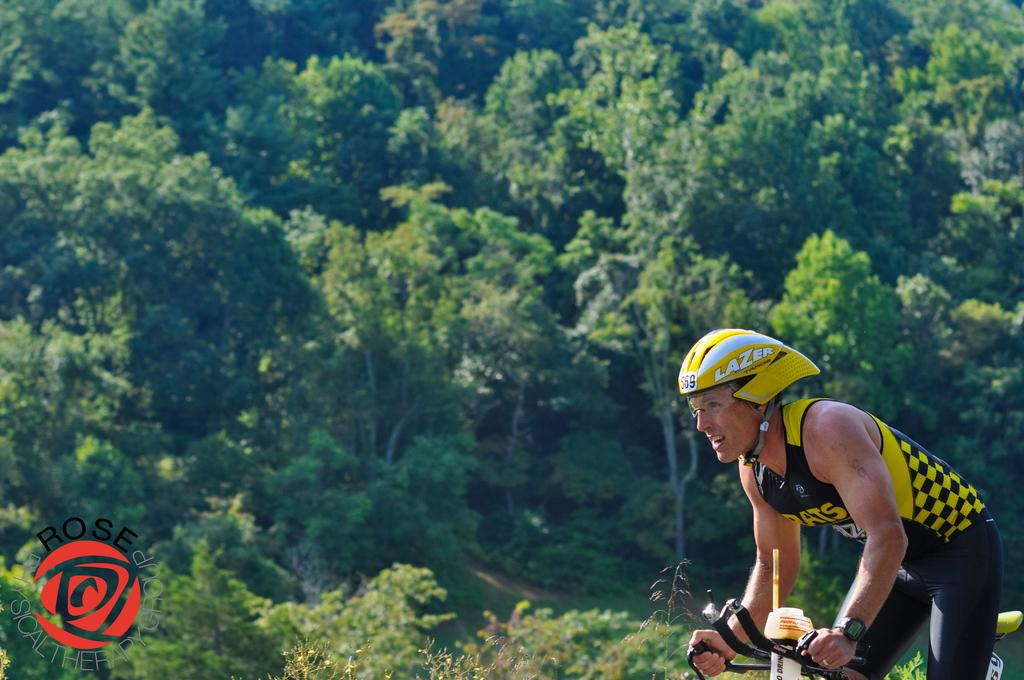What is the main subject of the image? There is a man in the image. What is the man doing in the image? The man is riding a bicycle. What can be seen in the background of the image? There are trees in the background of the image. What type of meat is hanging from the trees in the image? There is no meat hanging from the trees in the image; only trees are visible in the background. 